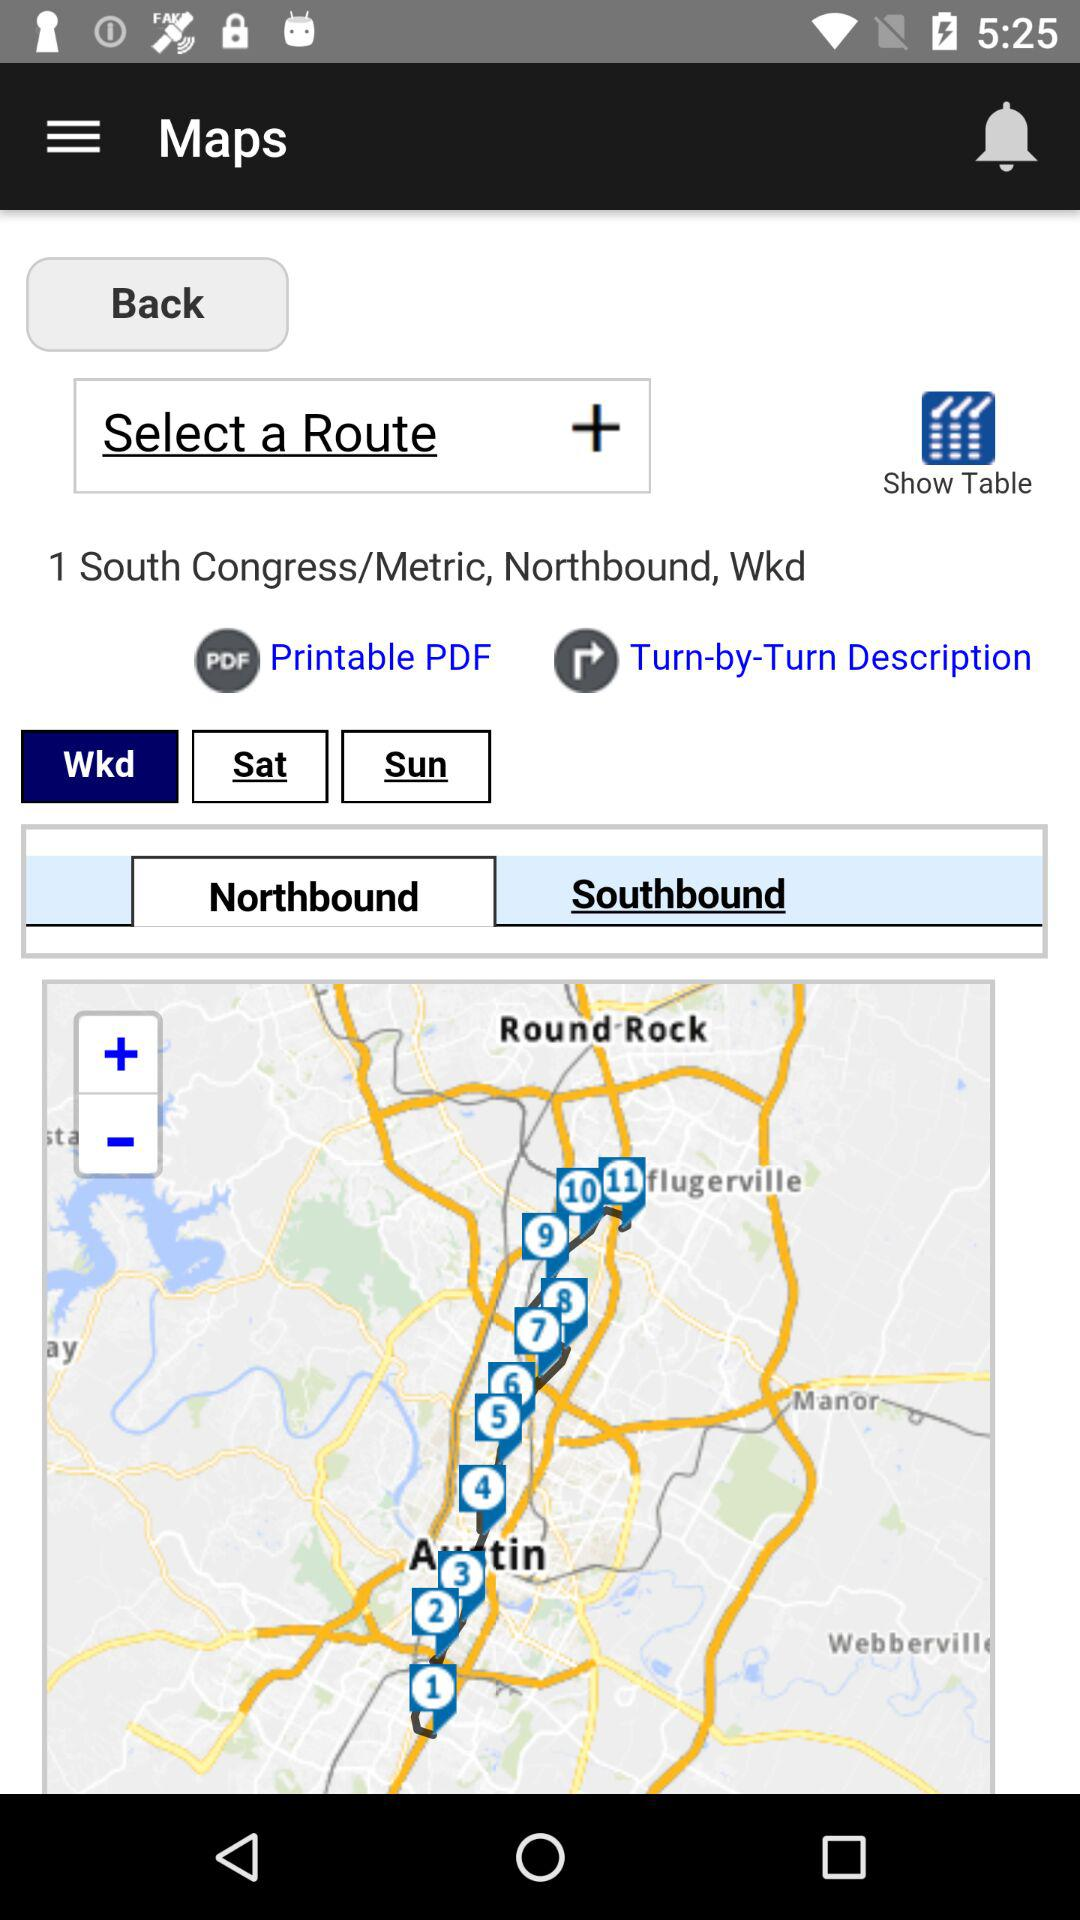Which tab is selected? The selected tabs are "Wkd" and "Northbound". 